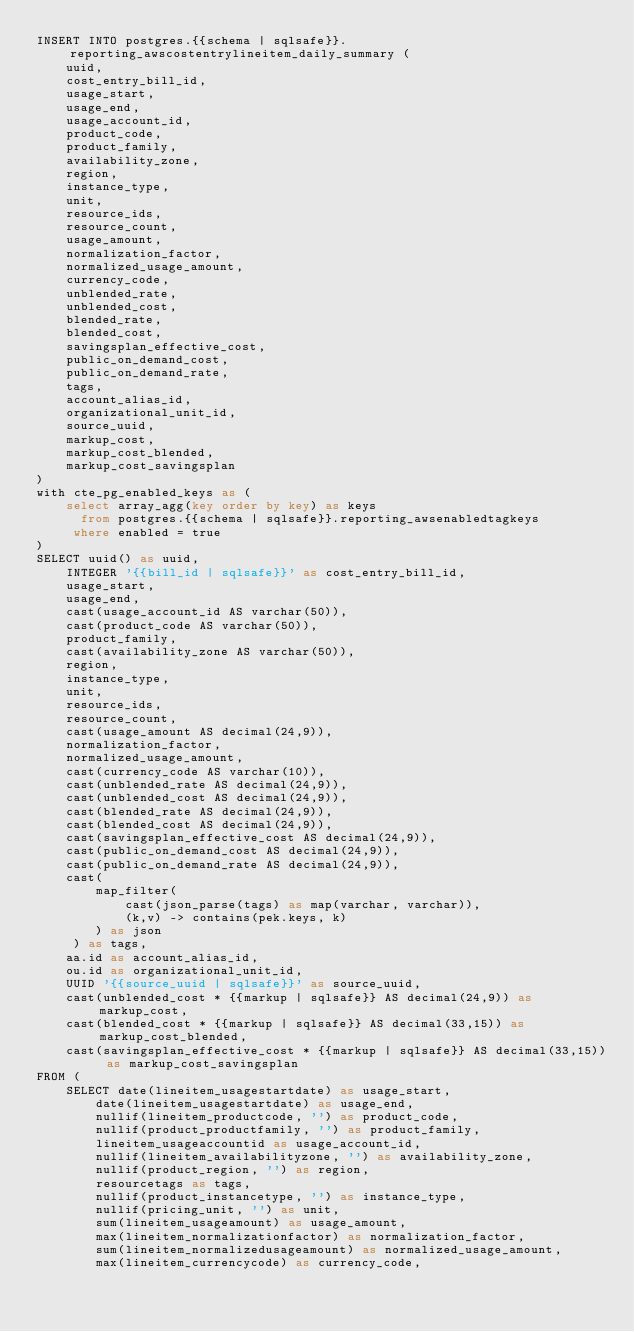<code> <loc_0><loc_0><loc_500><loc_500><_SQL_>INSERT INTO postgres.{{schema | sqlsafe}}.reporting_awscostentrylineitem_daily_summary (
    uuid,
    cost_entry_bill_id,
    usage_start,
    usage_end,
    usage_account_id,
    product_code,
    product_family,
    availability_zone,
    region,
    instance_type,
    unit,
    resource_ids,
    resource_count,
    usage_amount,
    normalization_factor,
    normalized_usage_amount,
    currency_code,
    unblended_rate,
    unblended_cost,
    blended_rate,
    blended_cost,
    savingsplan_effective_cost,
    public_on_demand_cost,
    public_on_demand_rate,
    tags,
    account_alias_id,
    organizational_unit_id,
    source_uuid,
    markup_cost,
    markup_cost_blended,
    markup_cost_savingsplan
)
with cte_pg_enabled_keys as (
    select array_agg(key order by key) as keys
      from postgres.{{schema | sqlsafe}}.reporting_awsenabledtagkeys
     where enabled = true
)
SELECT uuid() as uuid,
    INTEGER '{{bill_id | sqlsafe}}' as cost_entry_bill_id,
    usage_start,
    usage_end,
    cast(usage_account_id AS varchar(50)),
    cast(product_code AS varchar(50)),
    product_family,
    cast(availability_zone AS varchar(50)),
    region,
    instance_type,
    unit,
    resource_ids,
    resource_count,
    cast(usage_amount AS decimal(24,9)),
    normalization_factor,
    normalized_usage_amount,
    cast(currency_code AS varchar(10)),
    cast(unblended_rate AS decimal(24,9)),
    cast(unblended_cost AS decimal(24,9)),
    cast(blended_rate AS decimal(24,9)),
    cast(blended_cost AS decimal(24,9)),
    cast(savingsplan_effective_cost AS decimal(24,9)),
    cast(public_on_demand_cost AS decimal(24,9)),
    cast(public_on_demand_rate AS decimal(24,9)),
    cast(
        map_filter(
            cast(json_parse(tags) as map(varchar, varchar)),
            (k,v) -> contains(pek.keys, k)
        ) as json
     ) as tags,
    aa.id as account_alias_id,
    ou.id as organizational_unit_id,
    UUID '{{source_uuid | sqlsafe}}' as source_uuid,
    cast(unblended_cost * {{markup | sqlsafe}} AS decimal(24,9)) as markup_cost,
    cast(blended_cost * {{markup | sqlsafe}} AS decimal(33,15)) as markup_cost_blended,
    cast(savingsplan_effective_cost * {{markup | sqlsafe}} AS decimal(33,15)) as markup_cost_savingsplan
FROM (
    SELECT date(lineitem_usagestartdate) as usage_start,
        date(lineitem_usagestartdate) as usage_end,
        nullif(lineitem_productcode, '') as product_code,
        nullif(product_productfamily, '') as product_family,
        lineitem_usageaccountid as usage_account_id,
        nullif(lineitem_availabilityzone, '') as availability_zone,
        nullif(product_region, '') as region,
        resourcetags as tags,
        nullif(product_instancetype, '') as instance_type,
        nullif(pricing_unit, '') as unit,
        sum(lineitem_usageamount) as usage_amount,
        max(lineitem_normalizationfactor) as normalization_factor,
        sum(lineitem_normalizedusageamount) as normalized_usage_amount,
        max(lineitem_currencycode) as currency_code,</code> 